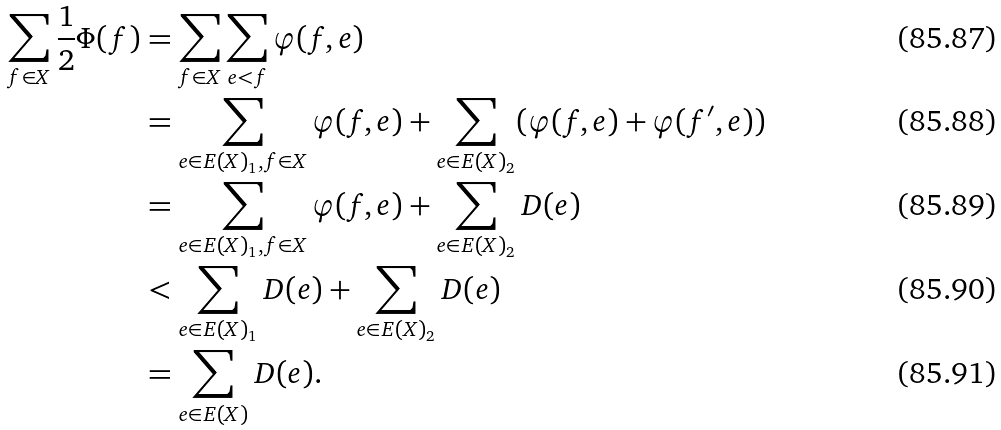<formula> <loc_0><loc_0><loc_500><loc_500>\sum _ { f \in X } \frac { 1 } { 2 } \Phi ( f ) & = \sum _ { f \in X } \sum _ { e < f } \varphi ( f , e ) \\ & = \sum _ { e \in E ( X ) _ { 1 } , f \in X } \varphi ( f , e ) + \sum _ { e \in E ( X ) _ { 2 } } ( \varphi ( f , e ) + \varphi ( f ^ { \prime } , e ) ) \\ & = \sum _ { e \in E ( X ) _ { 1 } , f \in X } \varphi ( f , e ) + \sum _ { e \in E ( X ) _ { 2 } } D ( e ) \\ & < \sum _ { e \in E ( X ) _ { 1 } } D ( e ) + \sum _ { e \in E ( X ) _ { 2 } } D ( e ) \\ & = \sum _ { e \in E ( X ) } D ( e ) .</formula> 